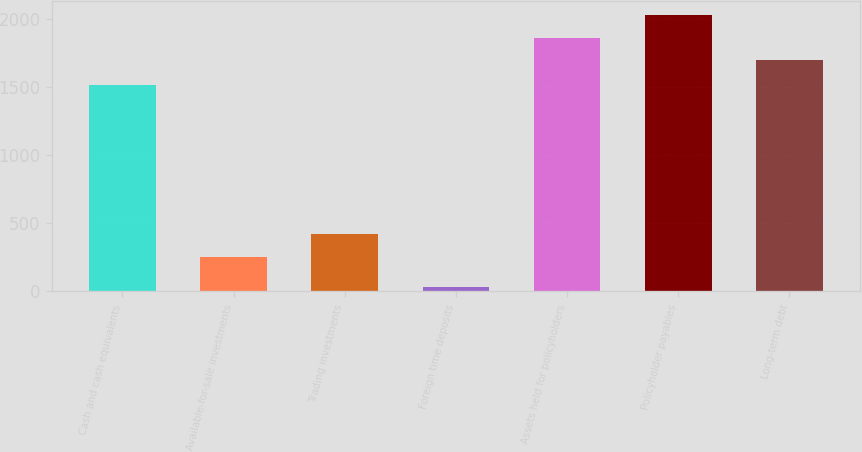<chart> <loc_0><loc_0><loc_500><loc_500><bar_chart><fcel>Cash and cash equivalents<fcel>Available-for-sale investments<fcel>Trading investments<fcel>Foreign time deposits<fcel>Assets held for policyholders<fcel>Policyholder payables<fcel>Long-term debt<nl><fcel>1514.2<fcel>255.9<fcel>422.73<fcel>29.6<fcel>1862.63<fcel>2029.46<fcel>1695.8<nl></chart> 